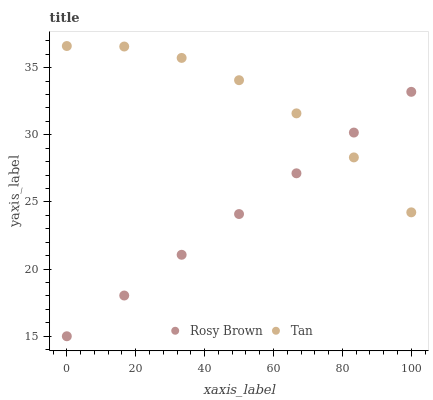Does Rosy Brown have the minimum area under the curve?
Answer yes or no. Yes. Does Tan have the maximum area under the curve?
Answer yes or no. Yes. Does Rosy Brown have the maximum area under the curve?
Answer yes or no. No. Is Rosy Brown the smoothest?
Answer yes or no. Yes. Is Tan the roughest?
Answer yes or no. Yes. Is Rosy Brown the roughest?
Answer yes or no. No. Does Rosy Brown have the lowest value?
Answer yes or no. Yes. Does Tan have the highest value?
Answer yes or no. Yes. Does Rosy Brown have the highest value?
Answer yes or no. No. Does Rosy Brown intersect Tan?
Answer yes or no. Yes. Is Rosy Brown less than Tan?
Answer yes or no. No. Is Rosy Brown greater than Tan?
Answer yes or no. No. 